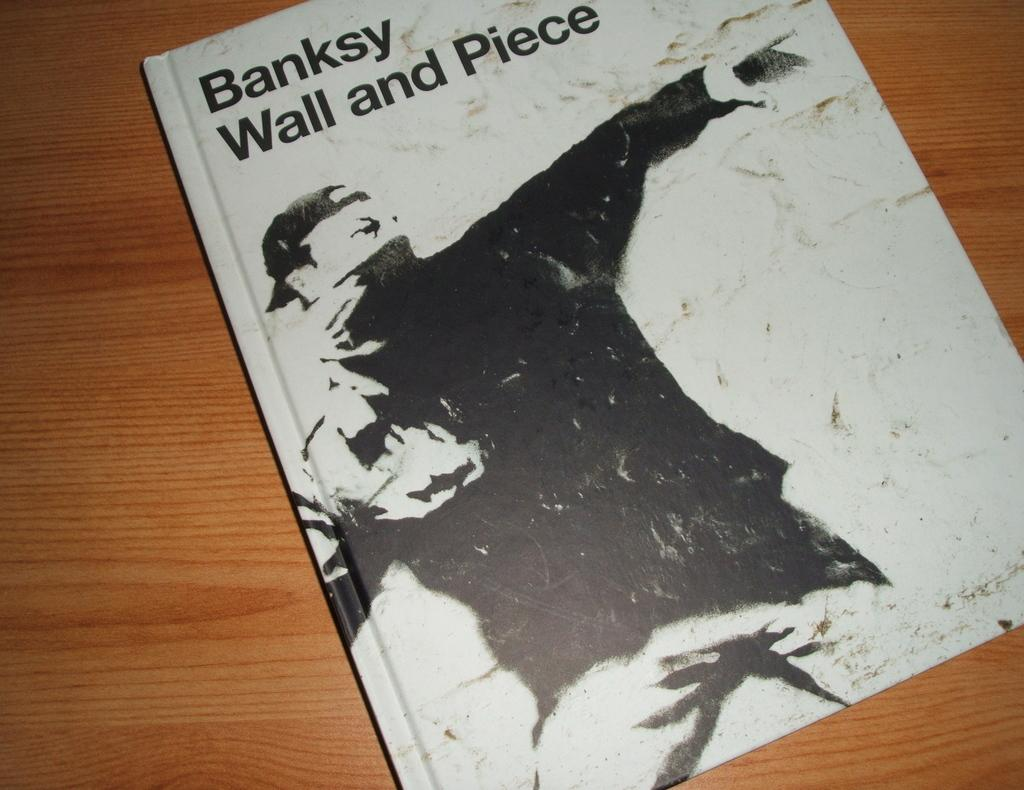<image>
Present a compact description of the photo's key features. A black and white hardback book about Bansky 